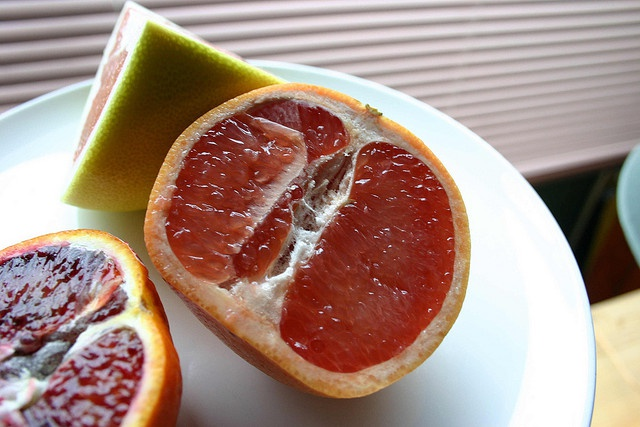Describe the objects in this image and their specific colors. I can see orange in gray, maroon, brown, and tan tones, orange in gray, darkgray, lightgray, maroon, and brown tones, and orange in gray, maroon, white, olive, and black tones in this image. 